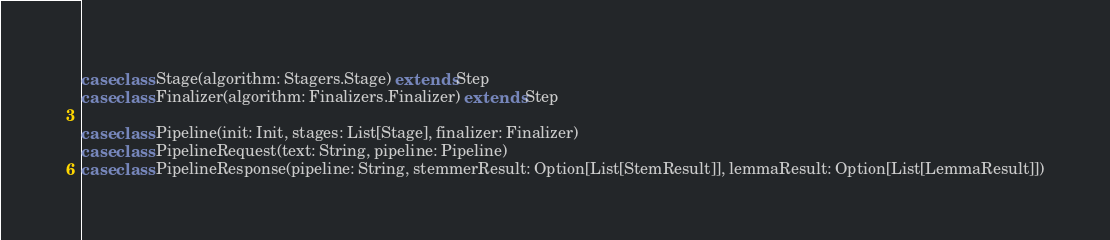<code> <loc_0><loc_0><loc_500><loc_500><_Scala_>case class Stage(algorithm: Stagers.Stage) extends Step
case class Finalizer(algorithm: Finalizers.Finalizer) extends Step

case class Pipeline(init: Init, stages: List[Stage], finalizer: Finalizer)
case class PipelineRequest(text: String, pipeline: Pipeline)
case class PipelineResponse(pipeline: String, stemmerResult: Option[List[StemResult]], lemmaResult: Option[List[LemmaResult]])
</code> 